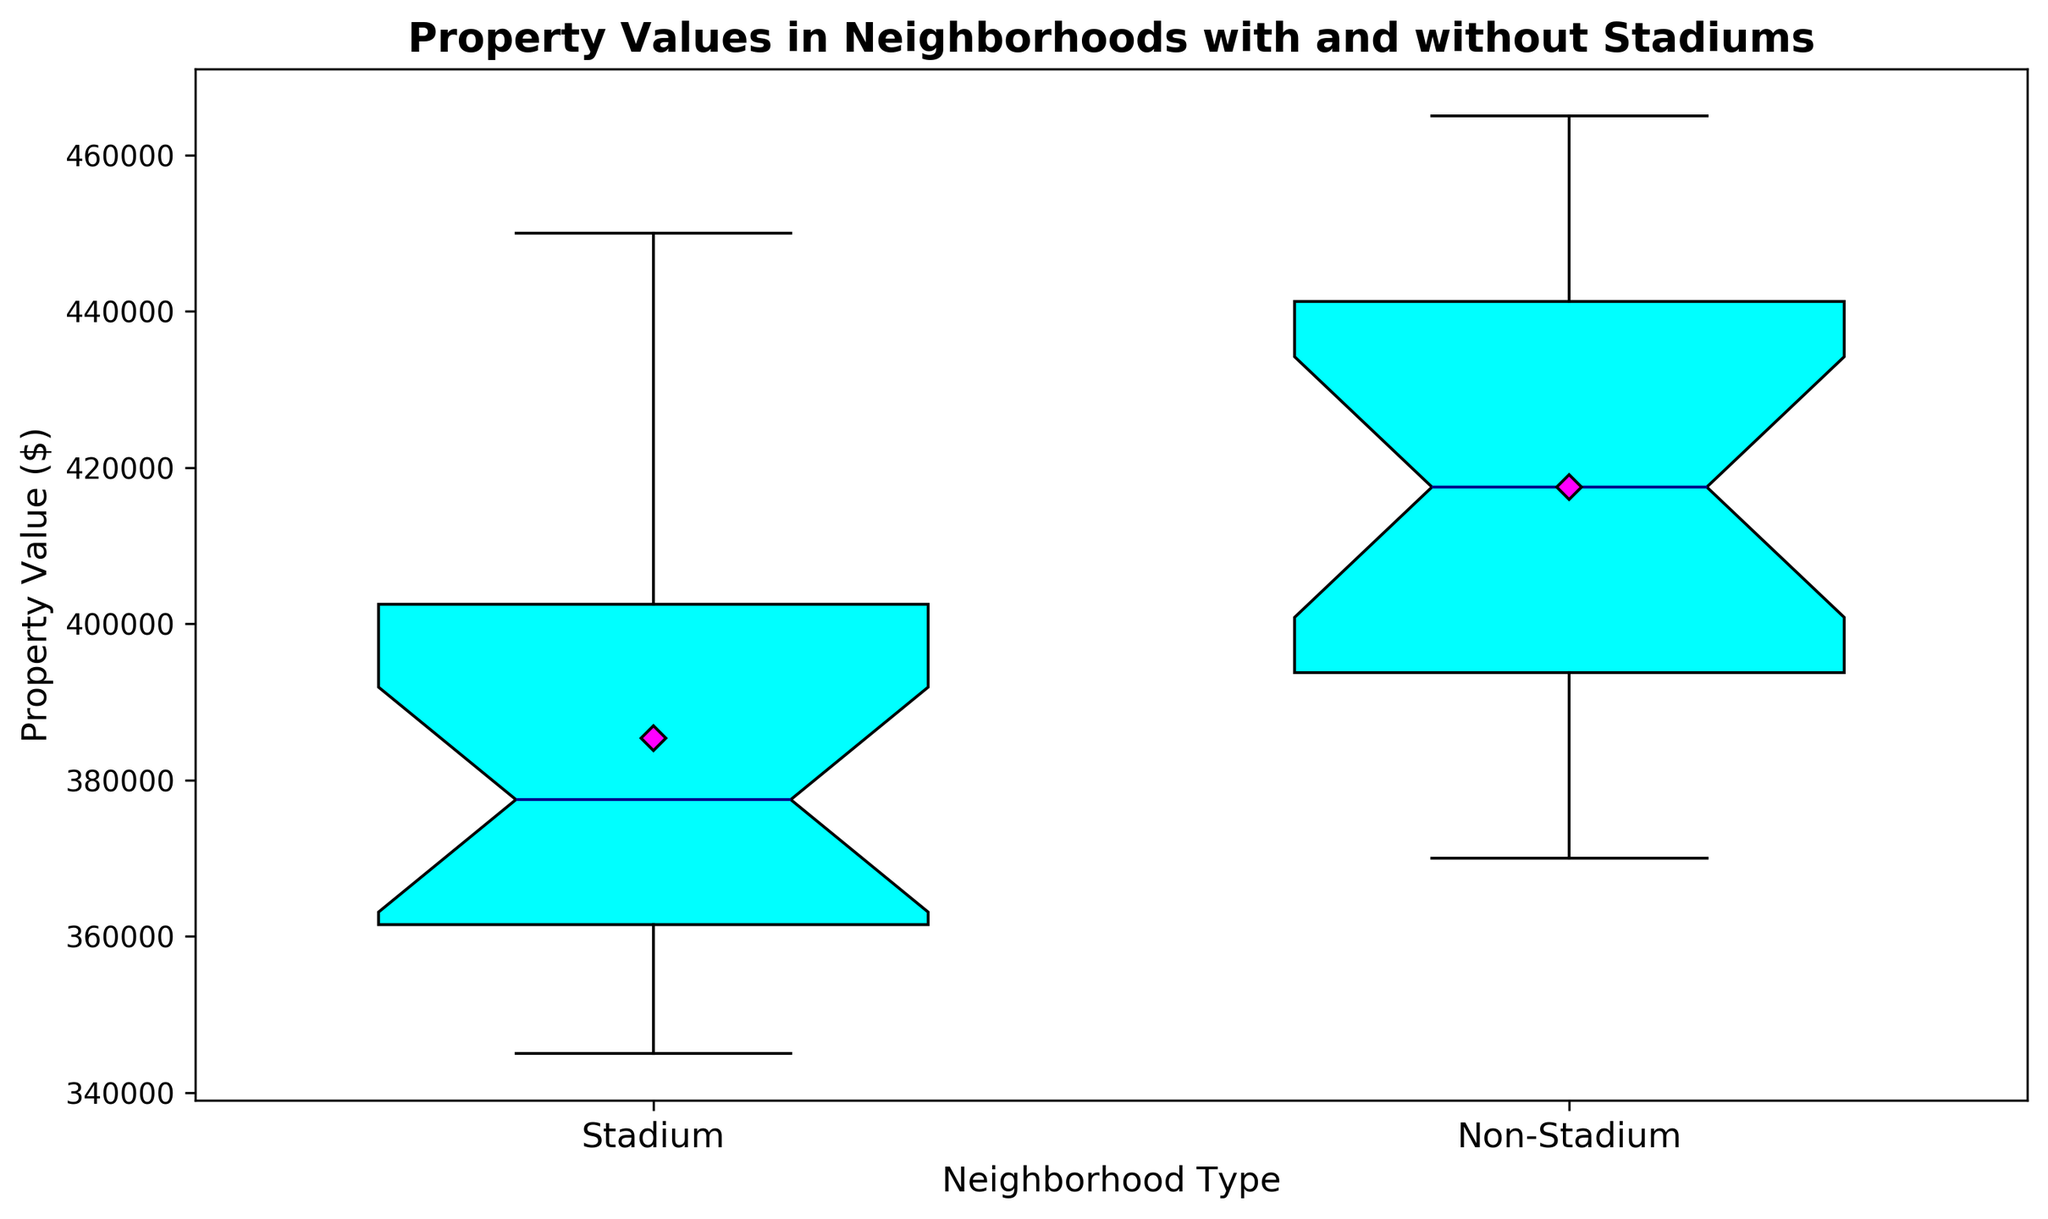What's the median property value for neighborhoods with stadiums? The median is indicated by the center line inside the box for the "Stadium" group.
Answer: The median is around $380,000 How does the mean property value compare between neighborhoods with and without stadiums? The means are marked by diamond shapes. Compare the height of the diamonds for "Stadium" and "Non-Stadium".
Answer: Non-Stadium mean is higher What is the interquartile range (IQR) of property values for neighborhoods without stadiums? The IQR is the length of the box. It measures the spread of the middle 50% of the data.
Answer: Roughly $75,000 Which neighborhood type shows greater variability in property values? Greater variability is indicated by the larger spread between the whiskers.
Answer: Stadium neighborhoods What is the approximate maximum property value for neighborhoods with stadiums? The maximum is the top end of the whisker or any outlier.
Answer: Around $450,000 Compare the lower quartile (25th percentile) of property values between the two neighborhood types. The lower quartile is the bottom line of each box. Compare where the boxes start.
Answer: Non-Stadium lower quartile is higher Are there any outliers in the property values for neighborhoods with stadiums? Outliers are indicated by points outside the whiskers.
Answer: No What is the difference between the medians of the two neighborhood types? Locate the median line for both groups and subtract the "Stadium" median from the "Non-Stadium" median.
Answer: Around $15,000 Does either neighborhood type have a skewed distribution? Skewness can be inferred if one whisker is longer than the other or if the median is closer to one quartile.
Answer: Both are relatively symmetric What color represents the boxes in the box plot? The boxes in the plot are colored. Identify the color of the filled box areas.
Answer: Cyan 